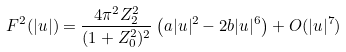<formula> <loc_0><loc_0><loc_500><loc_500>F ^ { 2 } ( | u | ) = \frac { 4 \pi ^ { 2 } Z _ { 2 } ^ { 2 } } { ( 1 + Z _ { 0 } ^ { 2 } ) ^ { 2 } } \left ( a | u | ^ { 2 } - 2 b | u | ^ { 6 } \right ) + O ( | u | ^ { 7 } )</formula> 